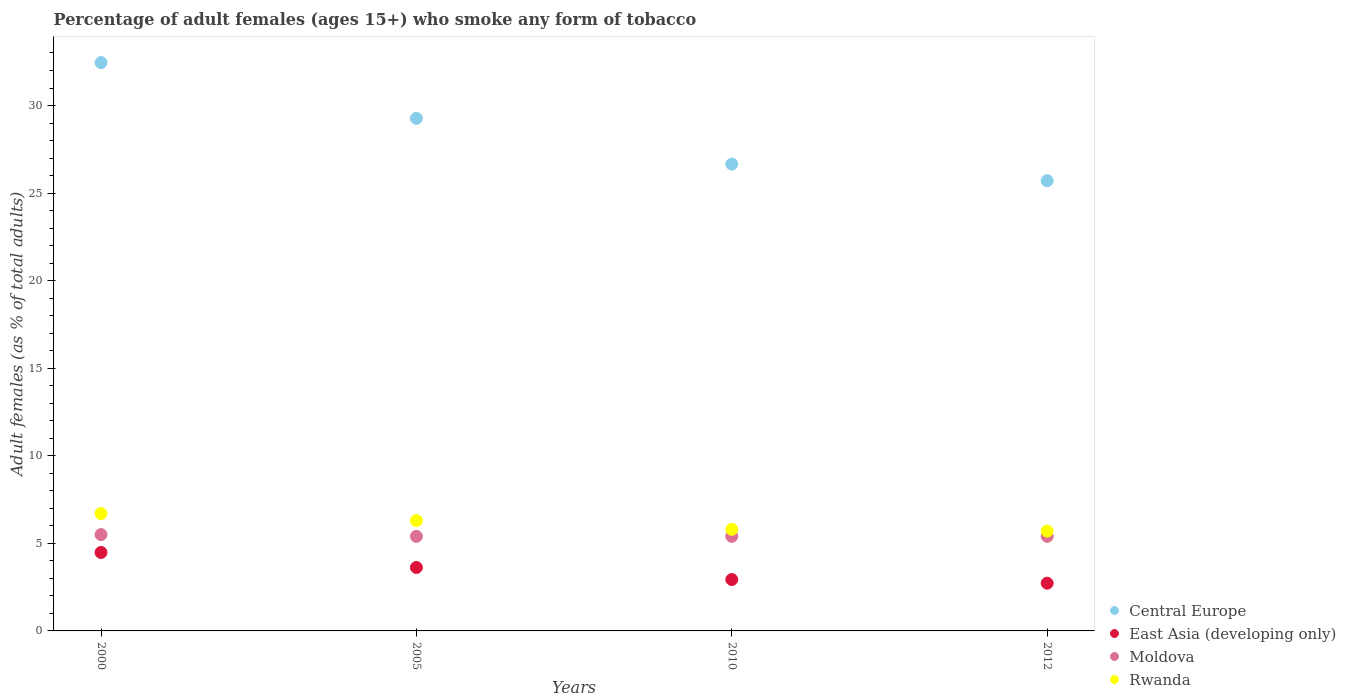Is the number of dotlines equal to the number of legend labels?
Provide a succinct answer. Yes. What is the percentage of adult females who smoke in Central Europe in 2012?
Ensure brevity in your answer.  25.71. Across all years, what is the maximum percentage of adult females who smoke in Moldova?
Make the answer very short. 5.5. Across all years, what is the minimum percentage of adult females who smoke in Moldova?
Provide a succinct answer. 5.4. In which year was the percentage of adult females who smoke in Rwanda maximum?
Offer a terse response. 2000. What is the total percentage of adult females who smoke in Central Europe in the graph?
Your answer should be very brief. 114.08. What is the difference between the percentage of adult females who smoke in Central Europe in 2005 and that in 2010?
Your answer should be very brief. 2.61. What is the difference between the percentage of adult females who smoke in Moldova in 2000 and the percentage of adult females who smoke in Rwanda in 2012?
Your response must be concise. -0.2. What is the average percentage of adult females who smoke in Rwanda per year?
Give a very brief answer. 6.12. In the year 2005, what is the difference between the percentage of adult females who smoke in Rwanda and percentage of adult females who smoke in Moldova?
Offer a terse response. 0.9. What is the ratio of the percentage of adult females who smoke in Rwanda in 2010 to that in 2012?
Keep it short and to the point. 1.02. Is the difference between the percentage of adult females who smoke in Rwanda in 2000 and 2010 greater than the difference between the percentage of adult females who smoke in Moldova in 2000 and 2010?
Your answer should be compact. Yes. What is the difference between the highest and the second highest percentage of adult females who smoke in Central Europe?
Your answer should be compact. 3.18. What is the difference between the highest and the lowest percentage of adult females who smoke in Rwanda?
Your answer should be very brief. 1. Is the sum of the percentage of adult females who smoke in East Asia (developing only) in 2000 and 2010 greater than the maximum percentage of adult females who smoke in Central Europe across all years?
Your answer should be very brief. No. Does the percentage of adult females who smoke in Moldova monotonically increase over the years?
Offer a terse response. No. Is the percentage of adult females who smoke in Central Europe strictly greater than the percentage of adult females who smoke in Moldova over the years?
Provide a succinct answer. Yes. Is the percentage of adult females who smoke in Moldova strictly less than the percentage of adult females who smoke in East Asia (developing only) over the years?
Ensure brevity in your answer.  No. How many years are there in the graph?
Ensure brevity in your answer.  4. What is the difference between two consecutive major ticks on the Y-axis?
Offer a terse response. 5. Are the values on the major ticks of Y-axis written in scientific E-notation?
Keep it short and to the point. No. Does the graph contain any zero values?
Provide a short and direct response. No. Does the graph contain grids?
Your response must be concise. No. Where does the legend appear in the graph?
Your response must be concise. Bottom right. How many legend labels are there?
Your answer should be very brief. 4. What is the title of the graph?
Make the answer very short. Percentage of adult females (ages 15+) who smoke any form of tobacco. Does "Madagascar" appear as one of the legend labels in the graph?
Provide a succinct answer. No. What is the label or title of the X-axis?
Provide a short and direct response. Years. What is the label or title of the Y-axis?
Keep it short and to the point. Adult females (as % of total adults). What is the Adult females (as % of total adults) of Central Europe in 2000?
Keep it short and to the point. 32.45. What is the Adult females (as % of total adults) in East Asia (developing only) in 2000?
Give a very brief answer. 4.48. What is the Adult females (as % of total adults) in Moldova in 2000?
Keep it short and to the point. 5.5. What is the Adult females (as % of total adults) in Central Europe in 2005?
Provide a short and direct response. 29.27. What is the Adult females (as % of total adults) of East Asia (developing only) in 2005?
Make the answer very short. 3.62. What is the Adult females (as % of total adults) in Rwanda in 2005?
Keep it short and to the point. 6.3. What is the Adult females (as % of total adults) in Central Europe in 2010?
Offer a very short reply. 26.65. What is the Adult females (as % of total adults) in East Asia (developing only) in 2010?
Ensure brevity in your answer.  2.93. What is the Adult females (as % of total adults) of Moldova in 2010?
Your answer should be very brief. 5.4. What is the Adult females (as % of total adults) in Central Europe in 2012?
Keep it short and to the point. 25.71. What is the Adult females (as % of total adults) of East Asia (developing only) in 2012?
Offer a terse response. 2.72. Across all years, what is the maximum Adult females (as % of total adults) of Central Europe?
Make the answer very short. 32.45. Across all years, what is the maximum Adult females (as % of total adults) in East Asia (developing only)?
Ensure brevity in your answer.  4.48. Across all years, what is the maximum Adult females (as % of total adults) of Moldova?
Provide a short and direct response. 5.5. Across all years, what is the minimum Adult females (as % of total adults) of Central Europe?
Keep it short and to the point. 25.71. Across all years, what is the minimum Adult females (as % of total adults) of East Asia (developing only)?
Provide a short and direct response. 2.72. Across all years, what is the minimum Adult females (as % of total adults) in Moldova?
Give a very brief answer. 5.4. Across all years, what is the minimum Adult females (as % of total adults) of Rwanda?
Keep it short and to the point. 5.7. What is the total Adult females (as % of total adults) of Central Europe in the graph?
Ensure brevity in your answer.  114.08. What is the total Adult females (as % of total adults) of East Asia (developing only) in the graph?
Provide a succinct answer. 13.76. What is the total Adult females (as % of total adults) in Moldova in the graph?
Your answer should be very brief. 21.7. What is the total Adult females (as % of total adults) of Rwanda in the graph?
Offer a very short reply. 24.5. What is the difference between the Adult females (as % of total adults) in Central Europe in 2000 and that in 2005?
Your response must be concise. 3.18. What is the difference between the Adult females (as % of total adults) in East Asia (developing only) in 2000 and that in 2005?
Offer a very short reply. 0.86. What is the difference between the Adult females (as % of total adults) in Central Europe in 2000 and that in 2010?
Your answer should be compact. 5.8. What is the difference between the Adult females (as % of total adults) of East Asia (developing only) in 2000 and that in 2010?
Offer a very short reply. 1.55. What is the difference between the Adult females (as % of total adults) of Moldova in 2000 and that in 2010?
Provide a short and direct response. 0.1. What is the difference between the Adult females (as % of total adults) of Central Europe in 2000 and that in 2012?
Your response must be concise. 6.74. What is the difference between the Adult females (as % of total adults) in East Asia (developing only) in 2000 and that in 2012?
Provide a succinct answer. 1.76. What is the difference between the Adult females (as % of total adults) of Central Europe in 2005 and that in 2010?
Keep it short and to the point. 2.61. What is the difference between the Adult females (as % of total adults) in East Asia (developing only) in 2005 and that in 2010?
Your answer should be compact. 0.69. What is the difference between the Adult females (as % of total adults) in Moldova in 2005 and that in 2010?
Provide a succinct answer. 0. What is the difference between the Adult females (as % of total adults) of Rwanda in 2005 and that in 2010?
Ensure brevity in your answer.  0.5. What is the difference between the Adult females (as % of total adults) of Central Europe in 2005 and that in 2012?
Your answer should be very brief. 3.56. What is the difference between the Adult females (as % of total adults) in East Asia (developing only) in 2005 and that in 2012?
Ensure brevity in your answer.  0.9. What is the difference between the Adult females (as % of total adults) in Rwanda in 2005 and that in 2012?
Keep it short and to the point. 0.6. What is the difference between the Adult females (as % of total adults) of Central Europe in 2010 and that in 2012?
Keep it short and to the point. 0.95. What is the difference between the Adult females (as % of total adults) in East Asia (developing only) in 2010 and that in 2012?
Offer a very short reply. 0.21. What is the difference between the Adult females (as % of total adults) of Moldova in 2010 and that in 2012?
Make the answer very short. 0. What is the difference between the Adult females (as % of total adults) in Central Europe in 2000 and the Adult females (as % of total adults) in East Asia (developing only) in 2005?
Make the answer very short. 28.83. What is the difference between the Adult females (as % of total adults) in Central Europe in 2000 and the Adult females (as % of total adults) in Moldova in 2005?
Give a very brief answer. 27.05. What is the difference between the Adult females (as % of total adults) of Central Europe in 2000 and the Adult females (as % of total adults) of Rwanda in 2005?
Give a very brief answer. 26.15. What is the difference between the Adult females (as % of total adults) of East Asia (developing only) in 2000 and the Adult females (as % of total adults) of Moldova in 2005?
Your answer should be compact. -0.92. What is the difference between the Adult females (as % of total adults) in East Asia (developing only) in 2000 and the Adult females (as % of total adults) in Rwanda in 2005?
Ensure brevity in your answer.  -1.82. What is the difference between the Adult females (as % of total adults) of Moldova in 2000 and the Adult females (as % of total adults) of Rwanda in 2005?
Your answer should be very brief. -0.8. What is the difference between the Adult females (as % of total adults) of Central Europe in 2000 and the Adult females (as % of total adults) of East Asia (developing only) in 2010?
Provide a succinct answer. 29.52. What is the difference between the Adult females (as % of total adults) of Central Europe in 2000 and the Adult females (as % of total adults) of Moldova in 2010?
Give a very brief answer. 27.05. What is the difference between the Adult females (as % of total adults) in Central Europe in 2000 and the Adult females (as % of total adults) in Rwanda in 2010?
Your response must be concise. 26.65. What is the difference between the Adult females (as % of total adults) of East Asia (developing only) in 2000 and the Adult females (as % of total adults) of Moldova in 2010?
Your answer should be compact. -0.92. What is the difference between the Adult females (as % of total adults) of East Asia (developing only) in 2000 and the Adult females (as % of total adults) of Rwanda in 2010?
Offer a terse response. -1.32. What is the difference between the Adult females (as % of total adults) of Moldova in 2000 and the Adult females (as % of total adults) of Rwanda in 2010?
Offer a very short reply. -0.3. What is the difference between the Adult females (as % of total adults) in Central Europe in 2000 and the Adult females (as % of total adults) in East Asia (developing only) in 2012?
Ensure brevity in your answer.  29.73. What is the difference between the Adult females (as % of total adults) in Central Europe in 2000 and the Adult females (as % of total adults) in Moldova in 2012?
Your answer should be compact. 27.05. What is the difference between the Adult females (as % of total adults) in Central Europe in 2000 and the Adult females (as % of total adults) in Rwanda in 2012?
Your response must be concise. 26.75. What is the difference between the Adult females (as % of total adults) in East Asia (developing only) in 2000 and the Adult females (as % of total adults) in Moldova in 2012?
Your response must be concise. -0.92. What is the difference between the Adult females (as % of total adults) of East Asia (developing only) in 2000 and the Adult females (as % of total adults) of Rwanda in 2012?
Your answer should be very brief. -1.22. What is the difference between the Adult females (as % of total adults) of Moldova in 2000 and the Adult females (as % of total adults) of Rwanda in 2012?
Provide a succinct answer. -0.2. What is the difference between the Adult females (as % of total adults) in Central Europe in 2005 and the Adult females (as % of total adults) in East Asia (developing only) in 2010?
Give a very brief answer. 26.33. What is the difference between the Adult females (as % of total adults) of Central Europe in 2005 and the Adult females (as % of total adults) of Moldova in 2010?
Offer a terse response. 23.87. What is the difference between the Adult females (as % of total adults) of Central Europe in 2005 and the Adult females (as % of total adults) of Rwanda in 2010?
Your answer should be compact. 23.47. What is the difference between the Adult females (as % of total adults) of East Asia (developing only) in 2005 and the Adult females (as % of total adults) of Moldova in 2010?
Provide a succinct answer. -1.78. What is the difference between the Adult females (as % of total adults) in East Asia (developing only) in 2005 and the Adult females (as % of total adults) in Rwanda in 2010?
Give a very brief answer. -2.18. What is the difference between the Adult females (as % of total adults) in Central Europe in 2005 and the Adult females (as % of total adults) in East Asia (developing only) in 2012?
Your response must be concise. 26.54. What is the difference between the Adult females (as % of total adults) in Central Europe in 2005 and the Adult females (as % of total adults) in Moldova in 2012?
Offer a very short reply. 23.87. What is the difference between the Adult females (as % of total adults) in Central Europe in 2005 and the Adult females (as % of total adults) in Rwanda in 2012?
Give a very brief answer. 23.57. What is the difference between the Adult females (as % of total adults) in East Asia (developing only) in 2005 and the Adult females (as % of total adults) in Moldova in 2012?
Give a very brief answer. -1.78. What is the difference between the Adult females (as % of total adults) of East Asia (developing only) in 2005 and the Adult females (as % of total adults) of Rwanda in 2012?
Ensure brevity in your answer.  -2.08. What is the difference between the Adult females (as % of total adults) in Central Europe in 2010 and the Adult females (as % of total adults) in East Asia (developing only) in 2012?
Offer a very short reply. 23.93. What is the difference between the Adult females (as % of total adults) in Central Europe in 2010 and the Adult females (as % of total adults) in Moldova in 2012?
Keep it short and to the point. 21.25. What is the difference between the Adult females (as % of total adults) in Central Europe in 2010 and the Adult females (as % of total adults) in Rwanda in 2012?
Give a very brief answer. 20.95. What is the difference between the Adult females (as % of total adults) in East Asia (developing only) in 2010 and the Adult females (as % of total adults) in Moldova in 2012?
Give a very brief answer. -2.47. What is the difference between the Adult females (as % of total adults) in East Asia (developing only) in 2010 and the Adult females (as % of total adults) in Rwanda in 2012?
Keep it short and to the point. -2.77. What is the difference between the Adult females (as % of total adults) of Moldova in 2010 and the Adult females (as % of total adults) of Rwanda in 2012?
Your answer should be compact. -0.3. What is the average Adult females (as % of total adults) in Central Europe per year?
Ensure brevity in your answer.  28.52. What is the average Adult females (as % of total adults) in East Asia (developing only) per year?
Your response must be concise. 3.44. What is the average Adult females (as % of total adults) in Moldova per year?
Ensure brevity in your answer.  5.42. What is the average Adult females (as % of total adults) of Rwanda per year?
Your answer should be very brief. 6.12. In the year 2000, what is the difference between the Adult females (as % of total adults) in Central Europe and Adult females (as % of total adults) in East Asia (developing only)?
Offer a very short reply. 27.97. In the year 2000, what is the difference between the Adult females (as % of total adults) in Central Europe and Adult females (as % of total adults) in Moldova?
Your answer should be compact. 26.95. In the year 2000, what is the difference between the Adult females (as % of total adults) of Central Europe and Adult females (as % of total adults) of Rwanda?
Make the answer very short. 25.75. In the year 2000, what is the difference between the Adult females (as % of total adults) of East Asia (developing only) and Adult females (as % of total adults) of Moldova?
Provide a succinct answer. -1.02. In the year 2000, what is the difference between the Adult females (as % of total adults) in East Asia (developing only) and Adult females (as % of total adults) in Rwanda?
Ensure brevity in your answer.  -2.22. In the year 2000, what is the difference between the Adult females (as % of total adults) in Moldova and Adult females (as % of total adults) in Rwanda?
Keep it short and to the point. -1.2. In the year 2005, what is the difference between the Adult females (as % of total adults) in Central Europe and Adult females (as % of total adults) in East Asia (developing only)?
Your answer should be compact. 25.64. In the year 2005, what is the difference between the Adult females (as % of total adults) of Central Europe and Adult females (as % of total adults) of Moldova?
Provide a short and direct response. 23.87. In the year 2005, what is the difference between the Adult females (as % of total adults) in Central Europe and Adult females (as % of total adults) in Rwanda?
Your answer should be very brief. 22.97. In the year 2005, what is the difference between the Adult females (as % of total adults) in East Asia (developing only) and Adult females (as % of total adults) in Moldova?
Keep it short and to the point. -1.78. In the year 2005, what is the difference between the Adult females (as % of total adults) of East Asia (developing only) and Adult females (as % of total adults) of Rwanda?
Make the answer very short. -2.68. In the year 2005, what is the difference between the Adult females (as % of total adults) in Moldova and Adult females (as % of total adults) in Rwanda?
Keep it short and to the point. -0.9. In the year 2010, what is the difference between the Adult females (as % of total adults) in Central Europe and Adult females (as % of total adults) in East Asia (developing only)?
Your response must be concise. 23.72. In the year 2010, what is the difference between the Adult females (as % of total adults) in Central Europe and Adult females (as % of total adults) in Moldova?
Provide a succinct answer. 21.25. In the year 2010, what is the difference between the Adult females (as % of total adults) of Central Europe and Adult females (as % of total adults) of Rwanda?
Provide a short and direct response. 20.86. In the year 2010, what is the difference between the Adult females (as % of total adults) in East Asia (developing only) and Adult females (as % of total adults) in Moldova?
Your response must be concise. -2.47. In the year 2010, what is the difference between the Adult females (as % of total adults) in East Asia (developing only) and Adult females (as % of total adults) in Rwanda?
Provide a succinct answer. -2.87. In the year 2010, what is the difference between the Adult females (as % of total adults) of Moldova and Adult females (as % of total adults) of Rwanda?
Make the answer very short. -0.4. In the year 2012, what is the difference between the Adult females (as % of total adults) in Central Europe and Adult females (as % of total adults) in East Asia (developing only)?
Your answer should be compact. 22.98. In the year 2012, what is the difference between the Adult females (as % of total adults) of Central Europe and Adult females (as % of total adults) of Moldova?
Provide a short and direct response. 20.31. In the year 2012, what is the difference between the Adult females (as % of total adults) in Central Europe and Adult females (as % of total adults) in Rwanda?
Make the answer very short. 20.01. In the year 2012, what is the difference between the Adult females (as % of total adults) in East Asia (developing only) and Adult females (as % of total adults) in Moldova?
Your response must be concise. -2.68. In the year 2012, what is the difference between the Adult females (as % of total adults) of East Asia (developing only) and Adult females (as % of total adults) of Rwanda?
Provide a short and direct response. -2.98. What is the ratio of the Adult females (as % of total adults) in Central Europe in 2000 to that in 2005?
Ensure brevity in your answer.  1.11. What is the ratio of the Adult females (as % of total adults) of East Asia (developing only) in 2000 to that in 2005?
Ensure brevity in your answer.  1.24. What is the ratio of the Adult females (as % of total adults) of Moldova in 2000 to that in 2005?
Your response must be concise. 1.02. What is the ratio of the Adult females (as % of total adults) of Rwanda in 2000 to that in 2005?
Your answer should be very brief. 1.06. What is the ratio of the Adult females (as % of total adults) of Central Europe in 2000 to that in 2010?
Offer a terse response. 1.22. What is the ratio of the Adult females (as % of total adults) in East Asia (developing only) in 2000 to that in 2010?
Ensure brevity in your answer.  1.53. What is the ratio of the Adult females (as % of total adults) in Moldova in 2000 to that in 2010?
Make the answer very short. 1.02. What is the ratio of the Adult females (as % of total adults) of Rwanda in 2000 to that in 2010?
Provide a short and direct response. 1.16. What is the ratio of the Adult females (as % of total adults) in Central Europe in 2000 to that in 2012?
Your answer should be very brief. 1.26. What is the ratio of the Adult females (as % of total adults) in East Asia (developing only) in 2000 to that in 2012?
Give a very brief answer. 1.64. What is the ratio of the Adult females (as % of total adults) in Moldova in 2000 to that in 2012?
Give a very brief answer. 1.02. What is the ratio of the Adult females (as % of total adults) in Rwanda in 2000 to that in 2012?
Make the answer very short. 1.18. What is the ratio of the Adult females (as % of total adults) of Central Europe in 2005 to that in 2010?
Your answer should be very brief. 1.1. What is the ratio of the Adult females (as % of total adults) of East Asia (developing only) in 2005 to that in 2010?
Offer a very short reply. 1.24. What is the ratio of the Adult females (as % of total adults) in Moldova in 2005 to that in 2010?
Make the answer very short. 1. What is the ratio of the Adult females (as % of total adults) of Rwanda in 2005 to that in 2010?
Make the answer very short. 1.09. What is the ratio of the Adult females (as % of total adults) in Central Europe in 2005 to that in 2012?
Make the answer very short. 1.14. What is the ratio of the Adult females (as % of total adults) of East Asia (developing only) in 2005 to that in 2012?
Your answer should be compact. 1.33. What is the ratio of the Adult females (as % of total adults) in Rwanda in 2005 to that in 2012?
Provide a short and direct response. 1.11. What is the ratio of the Adult females (as % of total adults) of Central Europe in 2010 to that in 2012?
Keep it short and to the point. 1.04. What is the ratio of the Adult females (as % of total adults) of East Asia (developing only) in 2010 to that in 2012?
Your answer should be compact. 1.08. What is the ratio of the Adult females (as % of total adults) in Rwanda in 2010 to that in 2012?
Your answer should be very brief. 1.02. What is the difference between the highest and the second highest Adult females (as % of total adults) of Central Europe?
Keep it short and to the point. 3.18. What is the difference between the highest and the second highest Adult females (as % of total adults) in East Asia (developing only)?
Offer a terse response. 0.86. What is the difference between the highest and the second highest Adult females (as % of total adults) in Moldova?
Provide a succinct answer. 0.1. What is the difference between the highest and the lowest Adult females (as % of total adults) in Central Europe?
Your answer should be very brief. 6.74. What is the difference between the highest and the lowest Adult females (as % of total adults) of East Asia (developing only)?
Provide a short and direct response. 1.76. What is the difference between the highest and the lowest Adult females (as % of total adults) in Rwanda?
Your response must be concise. 1. 